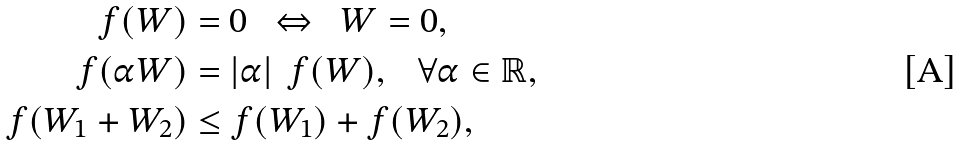<formula> <loc_0><loc_0><loc_500><loc_500>f ( W ) & = 0 \text { \ } \Leftrightarrow \text { \ } W = 0 , \\ \text {\ } f ( \alpha W ) & = \left | \alpha \right | \text { } f ( W ) , \text { \ \ } \forall \alpha \in \mathbb { R } , \\ f ( W _ { 1 } + W _ { 2 } ) & \leq f ( W _ { 1 } ) + f ( W _ { 2 } ) ,</formula> 